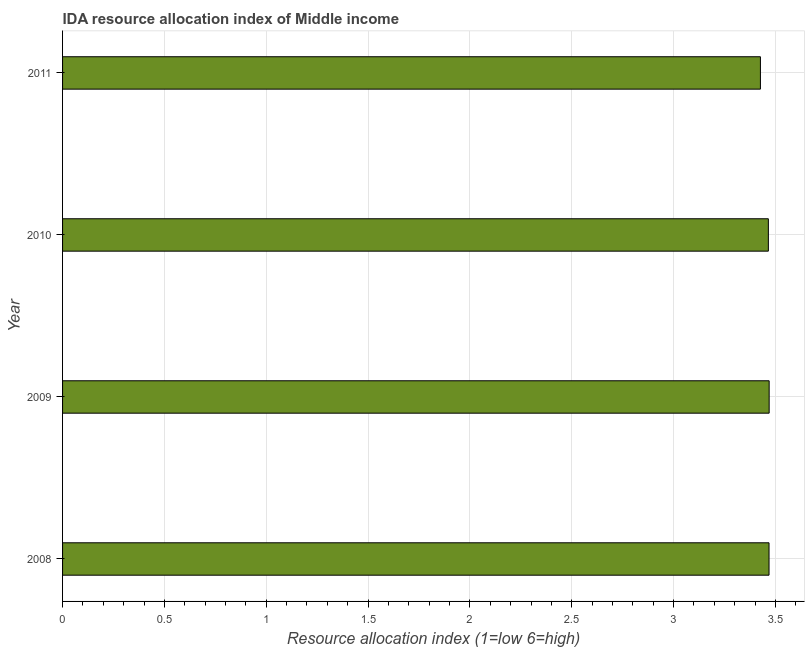Does the graph contain any zero values?
Ensure brevity in your answer.  No. What is the title of the graph?
Your response must be concise. IDA resource allocation index of Middle income. What is the label or title of the X-axis?
Give a very brief answer. Resource allocation index (1=low 6=high). What is the label or title of the Y-axis?
Make the answer very short. Year. What is the ida resource allocation index in 2009?
Give a very brief answer. 3.47. Across all years, what is the maximum ida resource allocation index?
Provide a succinct answer. 3.47. Across all years, what is the minimum ida resource allocation index?
Provide a succinct answer. 3.43. What is the sum of the ida resource allocation index?
Make the answer very short. 13.83. What is the difference between the ida resource allocation index in 2009 and 2010?
Your response must be concise. 0. What is the average ida resource allocation index per year?
Provide a succinct answer. 3.46. What is the median ida resource allocation index?
Keep it short and to the point. 3.47. Do a majority of the years between 2008 and 2011 (inclusive) have ida resource allocation index greater than 3.4 ?
Ensure brevity in your answer.  Yes. Is the difference between the ida resource allocation index in 2010 and 2011 greater than the difference between any two years?
Your answer should be compact. No. Is the sum of the ida resource allocation index in 2008 and 2009 greater than the maximum ida resource allocation index across all years?
Make the answer very short. Yes. Are all the bars in the graph horizontal?
Give a very brief answer. Yes. How many years are there in the graph?
Make the answer very short. 4. What is the Resource allocation index (1=low 6=high) in 2008?
Your answer should be very brief. 3.47. What is the Resource allocation index (1=low 6=high) in 2009?
Your answer should be compact. 3.47. What is the Resource allocation index (1=low 6=high) in 2010?
Keep it short and to the point. 3.47. What is the Resource allocation index (1=low 6=high) of 2011?
Offer a terse response. 3.43. What is the difference between the Resource allocation index (1=low 6=high) in 2008 and 2009?
Give a very brief answer. -0. What is the difference between the Resource allocation index (1=low 6=high) in 2008 and 2010?
Your response must be concise. 0. What is the difference between the Resource allocation index (1=low 6=high) in 2008 and 2011?
Offer a terse response. 0.04. What is the difference between the Resource allocation index (1=low 6=high) in 2009 and 2010?
Provide a short and direct response. 0. What is the difference between the Resource allocation index (1=low 6=high) in 2009 and 2011?
Provide a succinct answer. 0.04. What is the difference between the Resource allocation index (1=low 6=high) in 2010 and 2011?
Offer a terse response. 0.04. What is the ratio of the Resource allocation index (1=low 6=high) in 2008 to that in 2009?
Offer a very short reply. 1. What is the ratio of the Resource allocation index (1=low 6=high) in 2008 to that in 2011?
Your response must be concise. 1.01. What is the ratio of the Resource allocation index (1=low 6=high) in 2009 to that in 2010?
Provide a short and direct response. 1. 